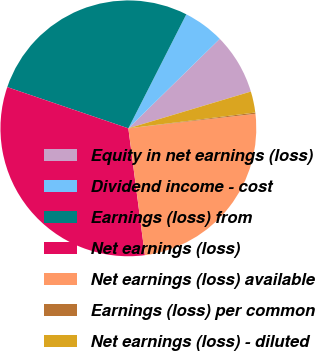<chart> <loc_0><loc_0><loc_500><loc_500><pie_chart><fcel>Equity in net earnings (loss)<fcel>Dividend income - cost<fcel>Earnings (loss) from<fcel>Net earnings (loss)<fcel>Net earnings (loss) available<fcel>Earnings (loss) per common<fcel>Net earnings (loss) - diluted<nl><fcel>7.69%<fcel>5.18%<fcel>27.26%<fcel>32.28%<fcel>24.75%<fcel>0.16%<fcel>2.67%<nl></chart> 